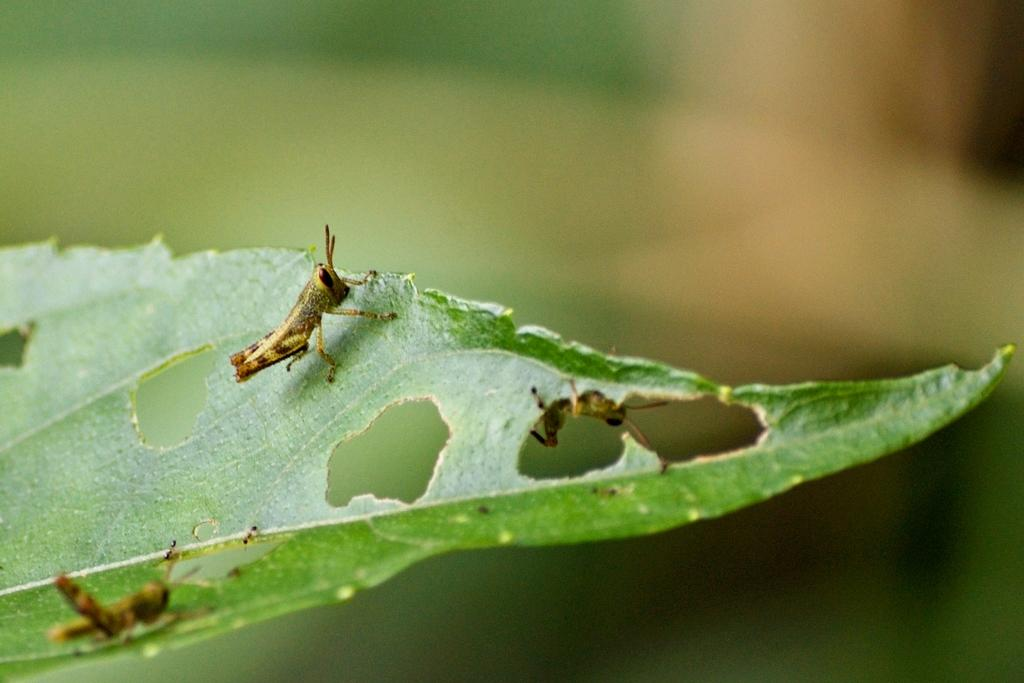What is the main subject of the image? The main subject of the image is insects on a leaf. Can you describe the background of the image? The background of the image is blurred. What type of sign can be seen in the image? There is no sign present in the image; it features insects on a leaf with a blurred background. What role does the quilt play in the image? There is no quilt present in the image. 